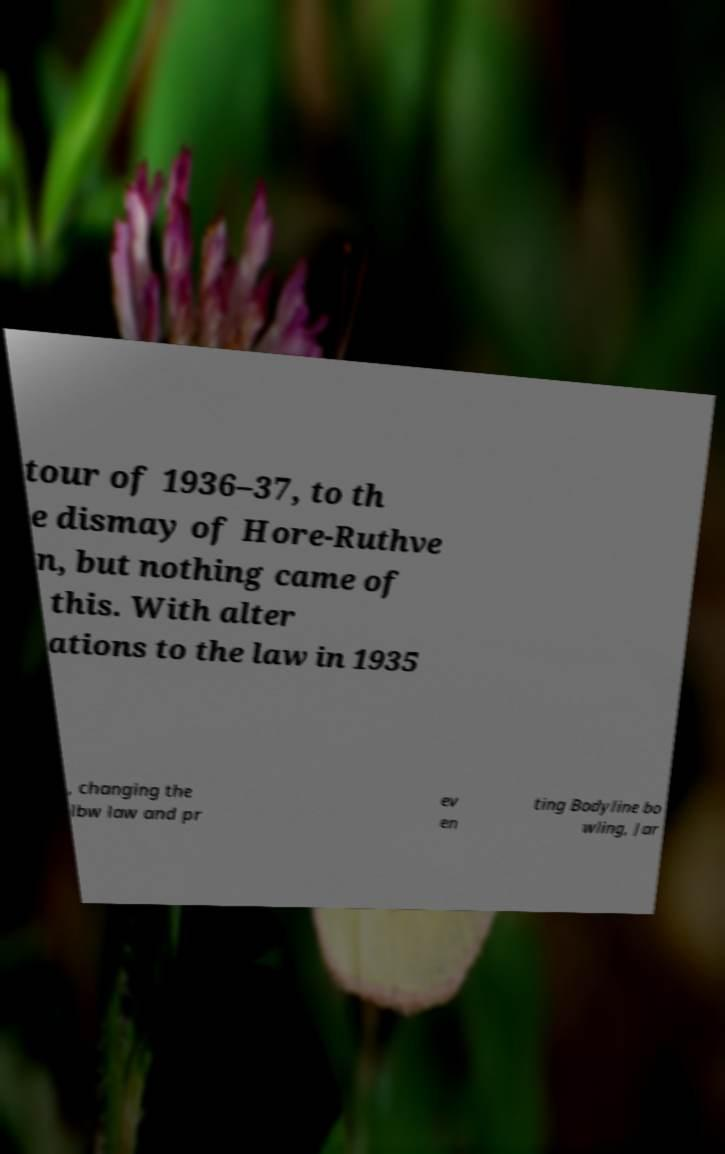What messages or text are displayed in this image? I need them in a readable, typed format. tour of 1936–37, to th e dismay of Hore-Ruthve n, but nothing came of this. With alter ations to the law in 1935 , changing the lbw law and pr ev en ting Bodyline bo wling, Jar 